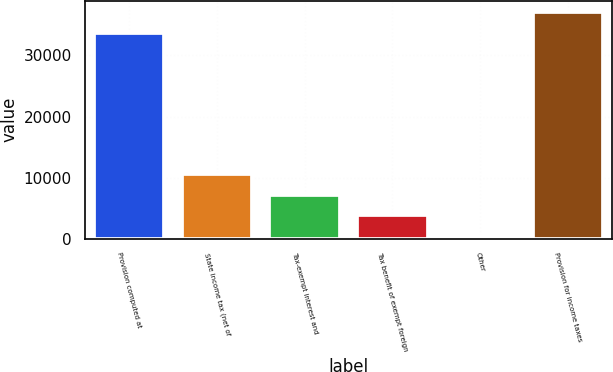Convert chart to OTSL. <chart><loc_0><loc_0><loc_500><loc_500><bar_chart><fcel>Provision computed at<fcel>State income tax (net of<fcel>Tax-exempt interest and<fcel>Tax benefit of exempt foreign<fcel>Other<fcel>Provision for income taxes<nl><fcel>33649<fcel>10639.9<fcel>7215.6<fcel>3791.3<fcel>367<fcel>37073.3<nl></chart> 